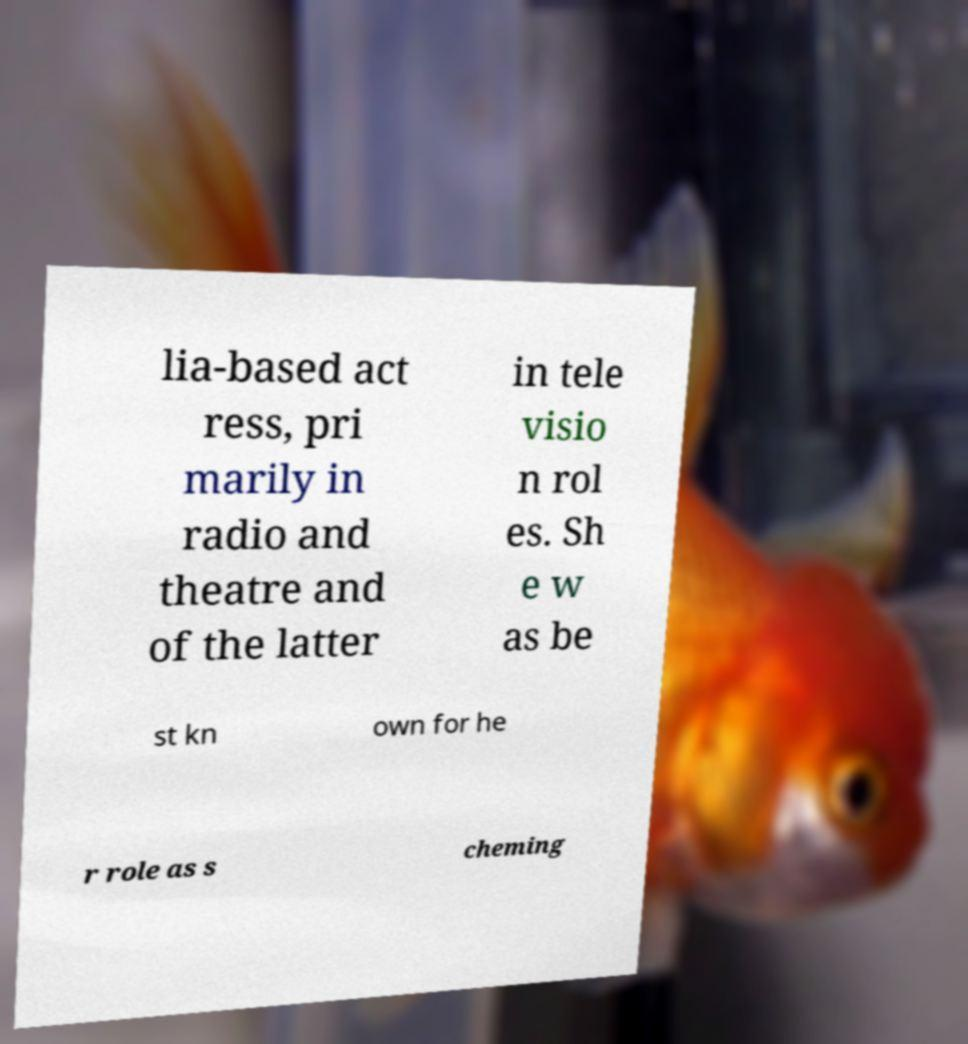There's text embedded in this image that I need extracted. Can you transcribe it verbatim? lia-based act ress, pri marily in radio and theatre and of the latter in tele visio n rol es. Sh e w as be st kn own for he r role as s cheming 